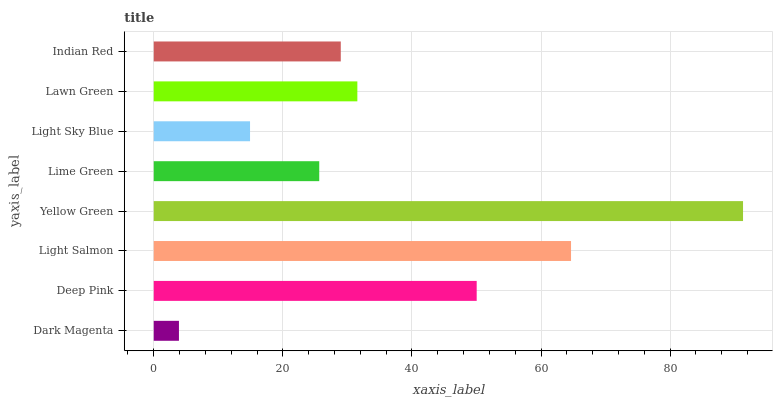Is Dark Magenta the minimum?
Answer yes or no. Yes. Is Yellow Green the maximum?
Answer yes or no. Yes. Is Deep Pink the minimum?
Answer yes or no. No. Is Deep Pink the maximum?
Answer yes or no. No. Is Deep Pink greater than Dark Magenta?
Answer yes or no. Yes. Is Dark Magenta less than Deep Pink?
Answer yes or no. Yes. Is Dark Magenta greater than Deep Pink?
Answer yes or no. No. Is Deep Pink less than Dark Magenta?
Answer yes or no. No. Is Lawn Green the high median?
Answer yes or no. Yes. Is Indian Red the low median?
Answer yes or no. Yes. Is Light Sky Blue the high median?
Answer yes or no. No. Is Lime Green the low median?
Answer yes or no. No. 